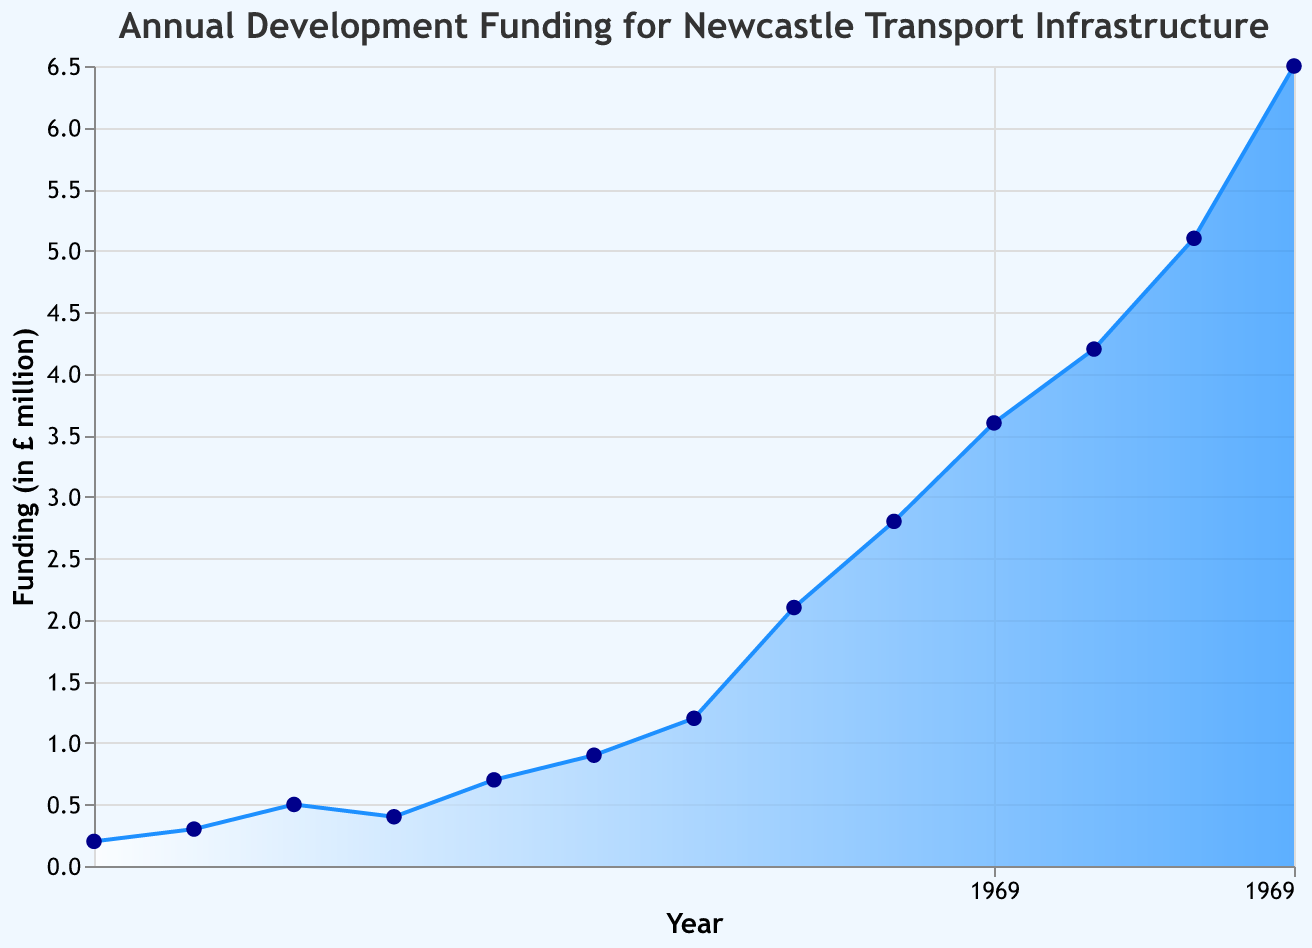What is the title of the chart? The title of the chart is located at the top. It reads "Annual Development Funding for Newcastle Transport Infrastructure".
Answer: Annual Development Funding for Newcastle Transport Infrastructure In which year was the annual development funding the highest? Look at the highest point on the y-axis, which corresponds to the year 2020 with a funding amount of £6.5 million.
Answer: 2020 How has the funding trend changed from 1900 to 2020? Observe the overall trend of the area chart from left to right. Funding has generally increased over time, with some fluctuations.
Answer: It has generally increased What is the funding amount in the year 1950? Locate the year 1950 on the x-axis and trace it up to the y-axis to find the corresponding funding amount, which is £0.9 million.
Answer: £0.9 million What is the difference in funding between 1920 and 1940? Find the funding amounts for 1920 (£0.5 million) and 1940 (£0.7 million). Subtract the funding in 1920 from the funding in 1940: 0.7 - 0.5 = £0.2 million.
Answer: £0.2 million Which decades saw the most significant increase in funding? Compare the increase in funding over each decade by observing the slope of the area chart. The most significant increases occur between 1960 to 1970 (£1.2 million to £2.1 million) and 2000 to 2010 (£4.2 million to £5.1 million).
Answer: 1960s and 2000s How does the funding in 2010 compare to the funding in 1980? Locate the funding amounts for both years on the chart: 1980 (£2.8 million) and 2010 (£5.1 million). Compare them directly.
Answer: 2010 funding is higher than 1980 What is the average annual development funding from 1900 to 2020? Sum all the funding amounts from 1900 to 2020 and divide by the number of years (13 data points). (0.2 + 0.3 + 0.5 + 0.4 + 0.7 + 0.9 + 1.2 + 2.1 + 2.8 + 3.6 + 4.2 + 5.1 + 6.5) / 13 = 28.5 / 13 ≈ £2.19 million per year.
Answer: £2.19 million What decade had a decrease in funding? Identify the periods where the area chart descends. From 1920 to 1930, the funding decreases from £0.5 million to £0.4 million.
Answer: 1920s 